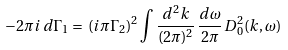Convert formula to latex. <formula><loc_0><loc_0><loc_500><loc_500>- 2 \pi i \, d { \Gamma _ { 1 } } = \, { ( i \pi \Gamma _ { 2 } ) ^ { 2 } } \int \frac { { d ^ { 2 } } k } { ( 2 \pi ) ^ { 2 } } \, \frac { d \omega } { 2 \pi } \, { D _ { 0 } ^ { 2 } } ( k , \omega )</formula> 